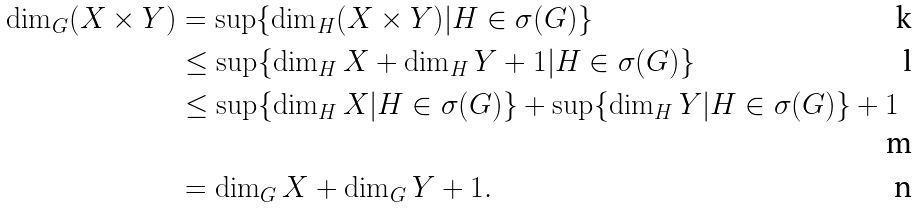<formula> <loc_0><loc_0><loc_500><loc_500>\dim _ { G } ( X \times Y ) & = \sup \{ \dim _ { H } ( X \times Y ) | H \in \sigma ( G ) \} \\ & \leq \sup \{ \dim _ { H } X + \dim _ { H } Y + 1 | H \in \sigma ( G ) \} \\ & \leq \sup \{ \dim _ { H } X | H \in \sigma ( G ) \} + \sup \{ \dim _ { H } Y | H \in \sigma ( G ) \} + 1 \\ & = \dim _ { G } X + \dim _ { G } Y + 1 .</formula> 